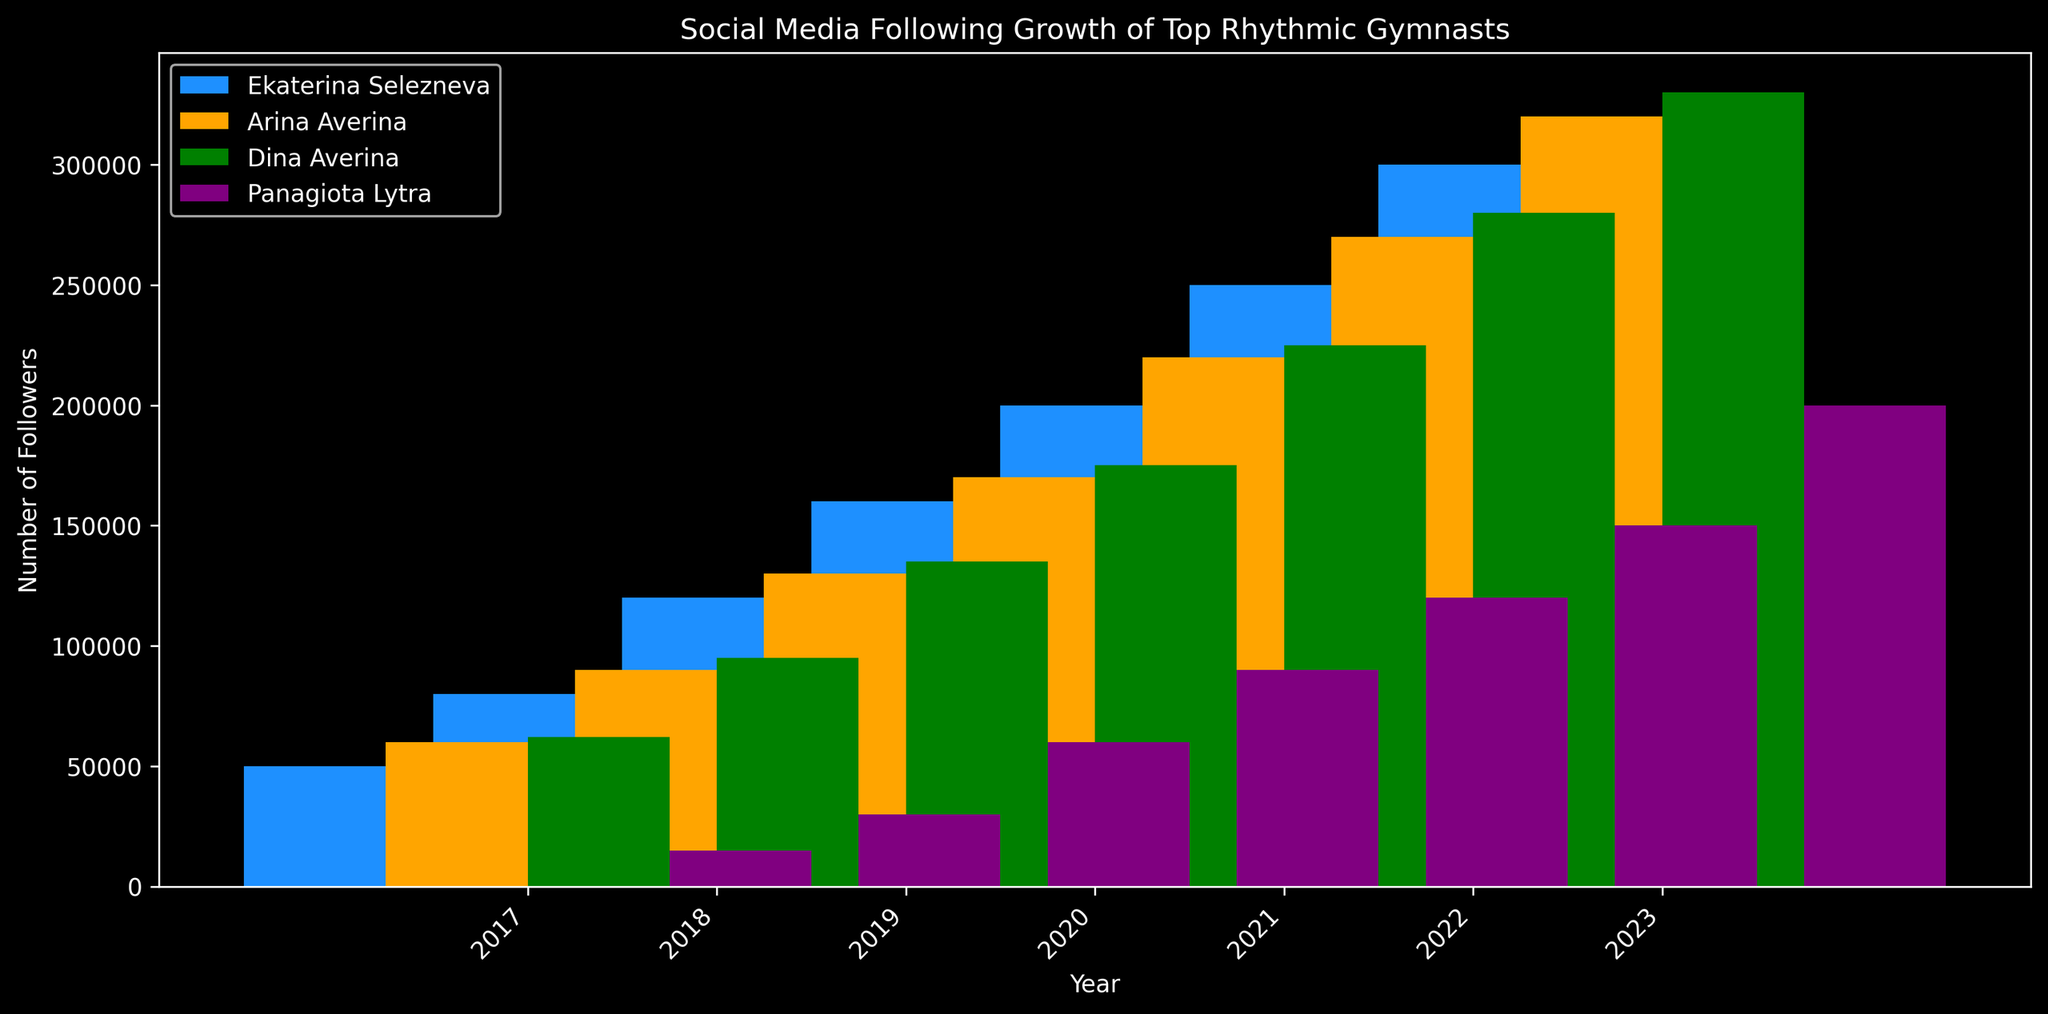Which gymnast had the highest number of followers in 2023? To find the answer, look at the bar representing 2023 and observe the height of the bars for each gymnast. The green bar (Dina Averina) is the tallest in 2023.
Answer: Dina Averina How many followers did Panagiota Lytra gain from 2017 to 2023? Subtract Panagiota Lytra's 2017 follower count from her 2023 follower count. The calculation is 200,000 (2023) - 15,000 (2017).
Answer: 185,000 Between which two consecutive years did Arina Averina see the largest increase in followers? Compare the increase in followers of Arina Averina between each consecutive year. The largest increase is from 2022 to 2023 where the followers increased from 270,000 to 320,000 (an increase of 50,000).
Answer: 2022 to 2023 In which year did Ekaterina Selezneva have double the followers she had in 2017? Look for the year in which Ekaterina Selezneva's followers are double 50,000 (100,000). In 2018, her followers were 80,000, which is not double. In 2019, she had 120,000 followers which is more than double.
Answer: 2019 How does Panagiota Lytra's follower count in 2021 compare to Dina Averina's in 2018? Compare the height of the purple bar for Panagiota Lytra in 2021 to the green bar for Dina Averina in 2018. Panagiota had 120,000 followers in 2021 and Dina had 95,000 in 2018. Panagiota's count is higher.
Answer: Panagiota Lytra had more followers What is the average number of followers for Panagiota Lytra between 2017 and 2023? Add the number of followers for Panagiota Lytra for each year from 2017 to 2023 and divide by the number of years (7). (15,000 + 30,000 + 60,000 + 90,000 + 120,000 + 150,000 + 200,000) / 7 = 665,000 / 7.
Answer: 95,000 By how many followers did Dina Averina's follower count exceed Ekaterina Selezneva's in 2023? Subtract Ekaterina Selezneva's followers in 2023 from Dina Averina's followers in 2023. The calculation is 330,000 - 300,000.
Answer: 30,000 Which gymnast showed the most consistent growth over the years? Consistent growth would mean a steady increase without large variations. By observing the bars, Dina Averina appears to show a steady increase each year.
Answer: Dina Averina In 2020, which gymnast had the least number of followers, and by how many followers did she trail the gymnast with the most followers? The shortest bar in 2020 belongs to Panagiota Lytra with 90,000 followers. The tallest bar belongs to Dina Averina with 175,000 followers. The difference is 175,000 - 90,000.
Answer: Panagiota Lytra, 85,000 followers What is the total number of followers for all four gymnasts combined in 2023? Sum the follower counts for all gymnasts in 2023: 300,000 (Ekaterina Selezneva) + 320,000 (Arina Averina) + 330,000 (Dina Averina) + 200,000 (Panagiota Lytra).
Answer: 1,150,000 